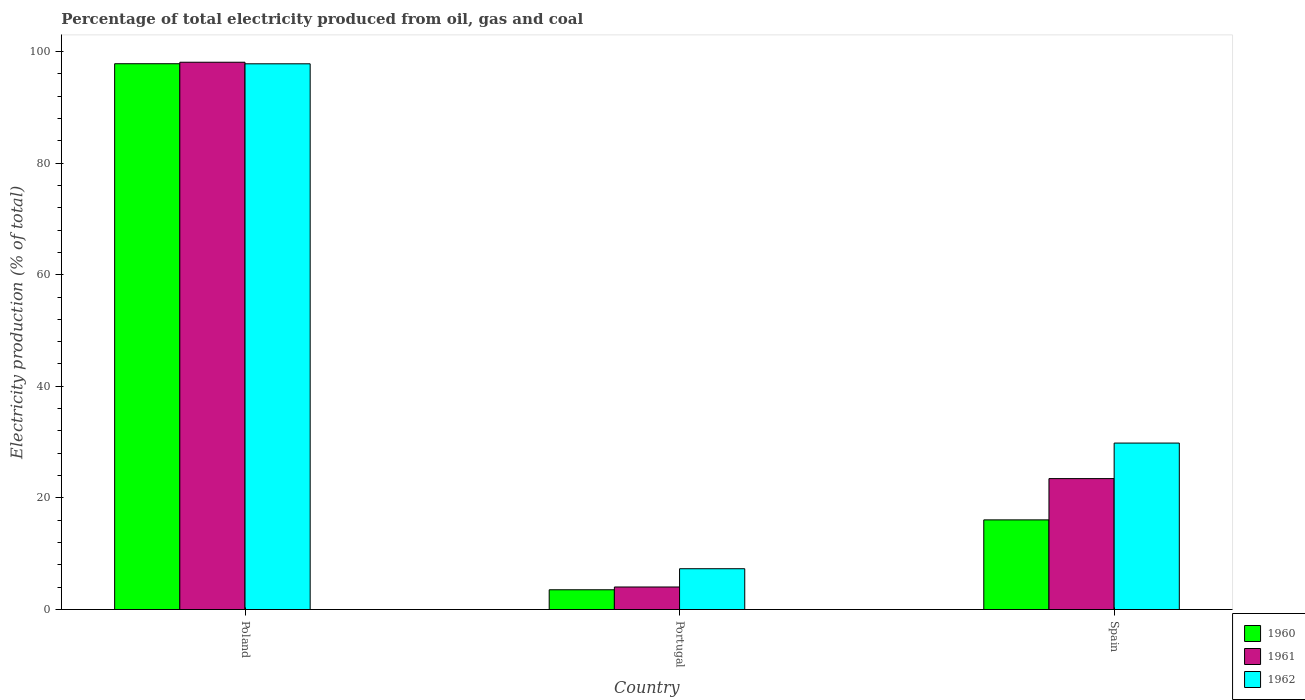How many groups of bars are there?
Your response must be concise. 3. How many bars are there on the 1st tick from the left?
Offer a very short reply. 3. How many bars are there on the 3rd tick from the right?
Give a very brief answer. 3. What is the electricity production in in 1961 in Poland?
Ensure brevity in your answer.  98.07. Across all countries, what is the maximum electricity production in in 1960?
Give a very brief answer. 97.8. Across all countries, what is the minimum electricity production in in 1962?
Keep it short and to the point. 7.31. In which country was the electricity production in in 1961 maximum?
Your answer should be compact. Poland. In which country was the electricity production in in 1961 minimum?
Ensure brevity in your answer.  Portugal. What is the total electricity production in in 1961 in the graph?
Provide a short and direct response. 125.56. What is the difference between the electricity production in in 1961 in Portugal and that in Spain?
Your answer should be very brief. -19.42. What is the difference between the electricity production in in 1960 in Spain and the electricity production in in 1962 in Poland?
Your answer should be very brief. -81.72. What is the average electricity production in in 1960 per country?
Make the answer very short. 39.13. What is the difference between the electricity production in of/in 1961 and electricity production in of/in 1960 in Poland?
Provide a succinct answer. 0.27. In how many countries, is the electricity production in in 1960 greater than 80 %?
Make the answer very short. 1. What is the ratio of the electricity production in in 1961 in Poland to that in Portugal?
Provide a succinct answer. 24.3. What is the difference between the highest and the second highest electricity production in in 1962?
Your answer should be very brief. 67.96. What is the difference between the highest and the lowest electricity production in in 1960?
Your answer should be compact. 94.26. Is the sum of the electricity production in in 1960 in Poland and Spain greater than the maximum electricity production in in 1962 across all countries?
Make the answer very short. Yes. What does the 1st bar from the left in Spain represents?
Provide a short and direct response. 1960. What does the 3rd bar from the right in Poland represents?
Ensure brevity in your answer.  1960. Are all the bars in the graph horizontal?
Your answer should be very brief. No. How many countries are there in the graph?
Provide a short and direct response. 3. Are the values on the major ticks of Y-axis written in scientific E-notation?
Your answer should be very brief. No. Does the graph contain any zero values?
Make the answer very short. No. Does the graph contain grids?
Your answer should be very brief. No. How are the legend labels stacked?
Your answer should be very brief. Vertical. What is the title of the graph?
Offer a very short reply. Percentage of total electricity produced from oil, gas and coal. What is the label or title of the X-axis?
Ensure brevity in your answer.  Country. What is the label or title of the Y-axis?
Provide a succinct answer. Electricity production (% of total). What is the Electricity production (% of total) in 1960 in Poland?
Make the answer very short. 97.8. What is the Electricity production (% of total) in 1961 in Poland?
Provide a short and direct response. 98.07. What is the Electricity production (% of total) of 1962 in Poland?
Your response must be concise. 97.79. What is the Electricity production (% of total) of 1960 in Portugal?
Keep it short and to the point. 3.54. What is the Electricity production (% of total) in 1961 in Portugal?
Make the answer very short. 4.04. What is the Electricity production (% of total) in 1962 in Portugal?
Your answer should be compact. 7.31. What is the Electricity production (% of total) in 1960 in Spain?
Your answer should be compact. 16.06. What is the Electricity production (% of total) in 1961 in Spain?
Offer a very short reply. 23.46. What is the Electricity production (% of total) of 1962 in Spain?
Give a very brief answer. 29.83. Across all countries, what is the maximum Electricity production (% of total) in 1960?
Keep it short and to the point. 97.8. Across all countries, what is the maximum Electricity production (% of total) of 1961?
Your response must be concise. 98.07. Across all countries, what is the maximum Electricity production (% of total) in 1962?
Your answer should be very brief. 97.79. Across all countries, what is the minimum Electricity production (% of total) in 1960?
Offer a very short reply. 3.54. Across all countries, what is the minimum Electricity production (% of total) in 1961?
Make the answer very short. 4.04. Across all countries, what is the minimum Electricity production (% of total) of 1962?
Keep it short and to the point. 7.31. What is the total Electricity production (% of total) of 1960 in the graph?
Offer a very short reply. 117.4. What is the total Electricity production (% of total) of 1961 in the graph?
Your answer should be compact. 125.56. What is the total Electricity production (% of total) in 1962 in the graph?
Keep it short and to the point. 134.92. What is the difference between the Electricity production (% of total) of 1960 in Poland and that in Portugal?
Your response must be concise. 94.26. What is the difference between the Electricity production (% of total) of 1961 in Poland and that in Portugal?
Ensure brevity in your answer.  94.03. What is the difference between the Electricity production (% of total) of 1962 in Poland and that in Portugal?
Ensure brevity in your answer.  90.48. What is the difference between the Electricity production (% of total) of 1960 in Poland and that in Spain?
Provide a short and direct response. 81.74. What is the difference between the Electricity production (% of total) of 1961 in Poland and that in Spain?
Offer a terse response. 74.61. What is the difference between the Electricity production (% of total) in 1962 in Poland and that in Spain?
Provide a succinct answer. 67.96. What is the difference between the Electricity production (% of total) in 1960 in Portugal and that in Spain?
Keep it short and to the point. -12.53. What is the difference between the Electricity production (% of total) of 1961 in Portugal and that in Spain?
Your answer should be very brief. -19.42. What is the difference between the Electricity production (% of total) in 1962 in Portugal and that in Spain?
Your response must be concise. -22.52. What is the difference between the Electricity production (% of total) in 1960 in Poland and the Electricity production (% of total) in 1961 in Portugal?
Provide a succinct answer. 93.76. What is the difference between the Electricity production (% of total) of 1960 in Poland and the Electricity production (% of total) of 1962 in Portugal?
Ensure brevity in your answer.  90.49. What is the difference between the Electricity production (% of total) in 1961 in Poland and the Electricity production (% of total) in 1962 in Portugal?
Offer a terse response. 90.76. What is the difference between the Electricity production (% of total) in 1960 in Poland and the Electricity production (% of total) in 1961 in Spain?
Provide a succinct answer. 74.34. What is the difference between the Electricity production (% of total) in 1960 in Poland and the Electricity production (% of total) in 1962 in Spain?
Your answer should be compact. 67.97. What is the difference between the Electricity production (% of total) of 1961 in Poland and the Electricity production (% of total) of 1962 in Spain?
Your answer should be compact. 68.24. What is the difference between the Electricity production (% of total) in 1960 in Portugal and the Electricity production (% of total) in 1961 in Spain?
Keep it short and to the point. -19.92. What is the difference between the Electricity production (% of total) in 1960 in Portugal and the Electricity production (% of total) in 1962 in Spain?
Offer a very short reply. -26.29. What is the difference between the Electricity production (% of total) of 1961 in Portugal and the Electricity production (% of total) of 1962 in Spain?
Provide a short and direct response. -25.79. What is the average Electricity production (% of total) in 1960 per country?
Your response must be concise. 39.13. What is the average Electricity production (% of total) of 1961 per country?
Your response must be concise. 41.85. What is the average Electricity production (% of total) of 1962 per country?
Make the answer very short. 44.97. What is the difference between the Electricity production (% of total) in 1960 and Electricity production (% of total) in 1961 in Poland?
Your answer should be compact. -0.27. What is the difference between the Electricity production (% of total) in 1960 and Electricity production (% of total) in 1962 in Poland?
Ensure brevity in your answer.  0.01. What is the difference between the Electricity production (% of total) of 1961 and Electricity production (% of total) of 1962 in Poland?
Keep it short and to the point. 0.28. What is the difference between the Electricity production (% of total) of 1960 and Electricity production (% of total) of 1961 in Portugal?
Keep it short and to the point. -0.5. What is the difference between the Electricity production (% of total) in 1960 and Electricity production (% of total) in 1962 in Portugal?
Ensure brevity in your answer.  -3.77. What is the difference between the Electricity production (% of total) in 1961 and Electricity production (% of total) in 1962 in Portugal?
Ensure brevity in your answer.  -3.27. What is the difference between the Electricity production (% of total) of 1960 and Electricity production (% of total) of 1961 in Spain?
Your answer should be very brief. -7.4. What is the difference between the Electricity production (% of total) of 1960 and Electricity production (% of total) of 1962 in Spain?
Ensure brevity in your answer.  -13.76. What is the difference between the Electricity production (% of total) in 1961 and Electricity production (% of total) in 1962 in Spain?
Provide a succinct answer. -6.37. What is the ratio of the Electricity production (% of total) in 1960 in Poland to that in Portugal?
Provide a short and direct response. 27.65. What is the ratio of the Electricity production (% of total) in 1961 in Poland to that in Portugal?
Provide a short and direct response. 24.3. What is the ratio of the Electricity production (% of total) in 1962 in Poland to that in Portugal?
Give a very brief answer. 13.38. What is the ratio of the Electricity production (% of total) in 1960 in Poland to that in Spain?
Give a very brief answer. 6.09. What is the ratio of the Electricity production (% of total) of 1961 in Poland to that in Spain?
Provide a succinct answer. 4.18. What is the ratio of the Electricity production (% of total) of 1962 in Poland to that in Spain?
Make the answer very short. 3.28. What is the ratio of the Electricity production (% of total) in 1960 in Portugal to that in Spain?
Your response must be concise. 0.22. What is the ratio of the Electricity production (% of total) of 1961 in Portugal to that in Spain?
Offer a terse response. 0.17. What is the ratio of the Electricity production (% of total) in 1962 in Portugal to that in Spain?
Make the answer very short. 0.24. What is the difference between the highest and the second highest Electricity production (% of total) of 1960?
Keep it short and to the point. 81.74. What is the difference between the highest and the second highest Electricity production (% of total) in 1961?
Your answer should be very brief. 74.61. What is the difference between the highest and the second highest Electricity production (% of total) in 1962?
Give a very brief answer. 67.96. What is the difference between the highest and the lowest Electricity production (% of total) in 1960?
Make the answer very short. 94.26. What is the difference between the highest and the lowest Electricity production (% of total) in 1961?
Offer a very short reply. 94.03. What is the difference between the highest and the lowest Electricity production (% of total) of 1962?
Provide a short and direct response. 90.48. 